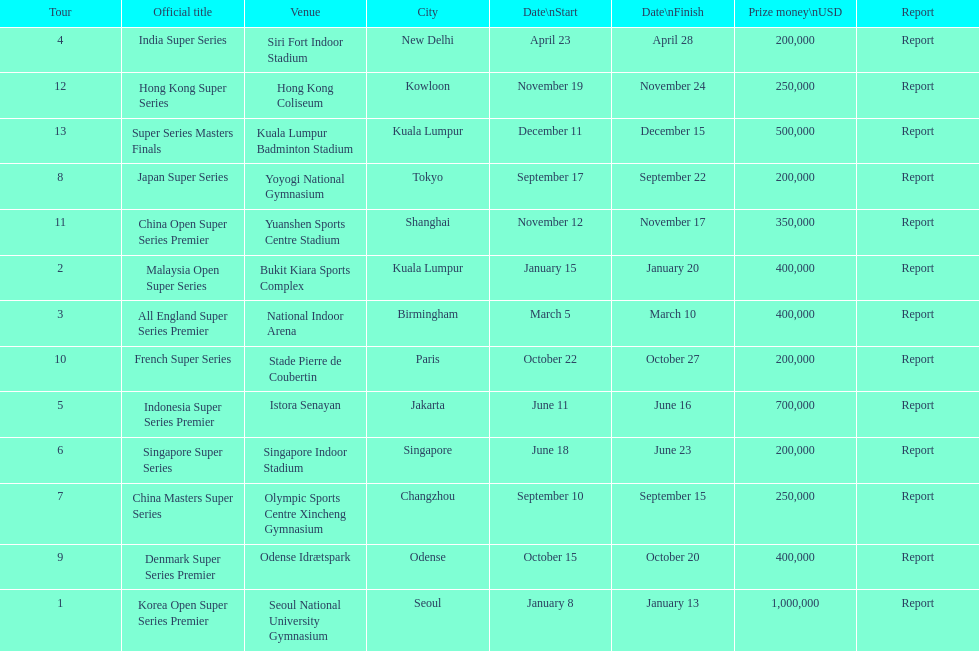How long did the japan super series take? 5 days. 